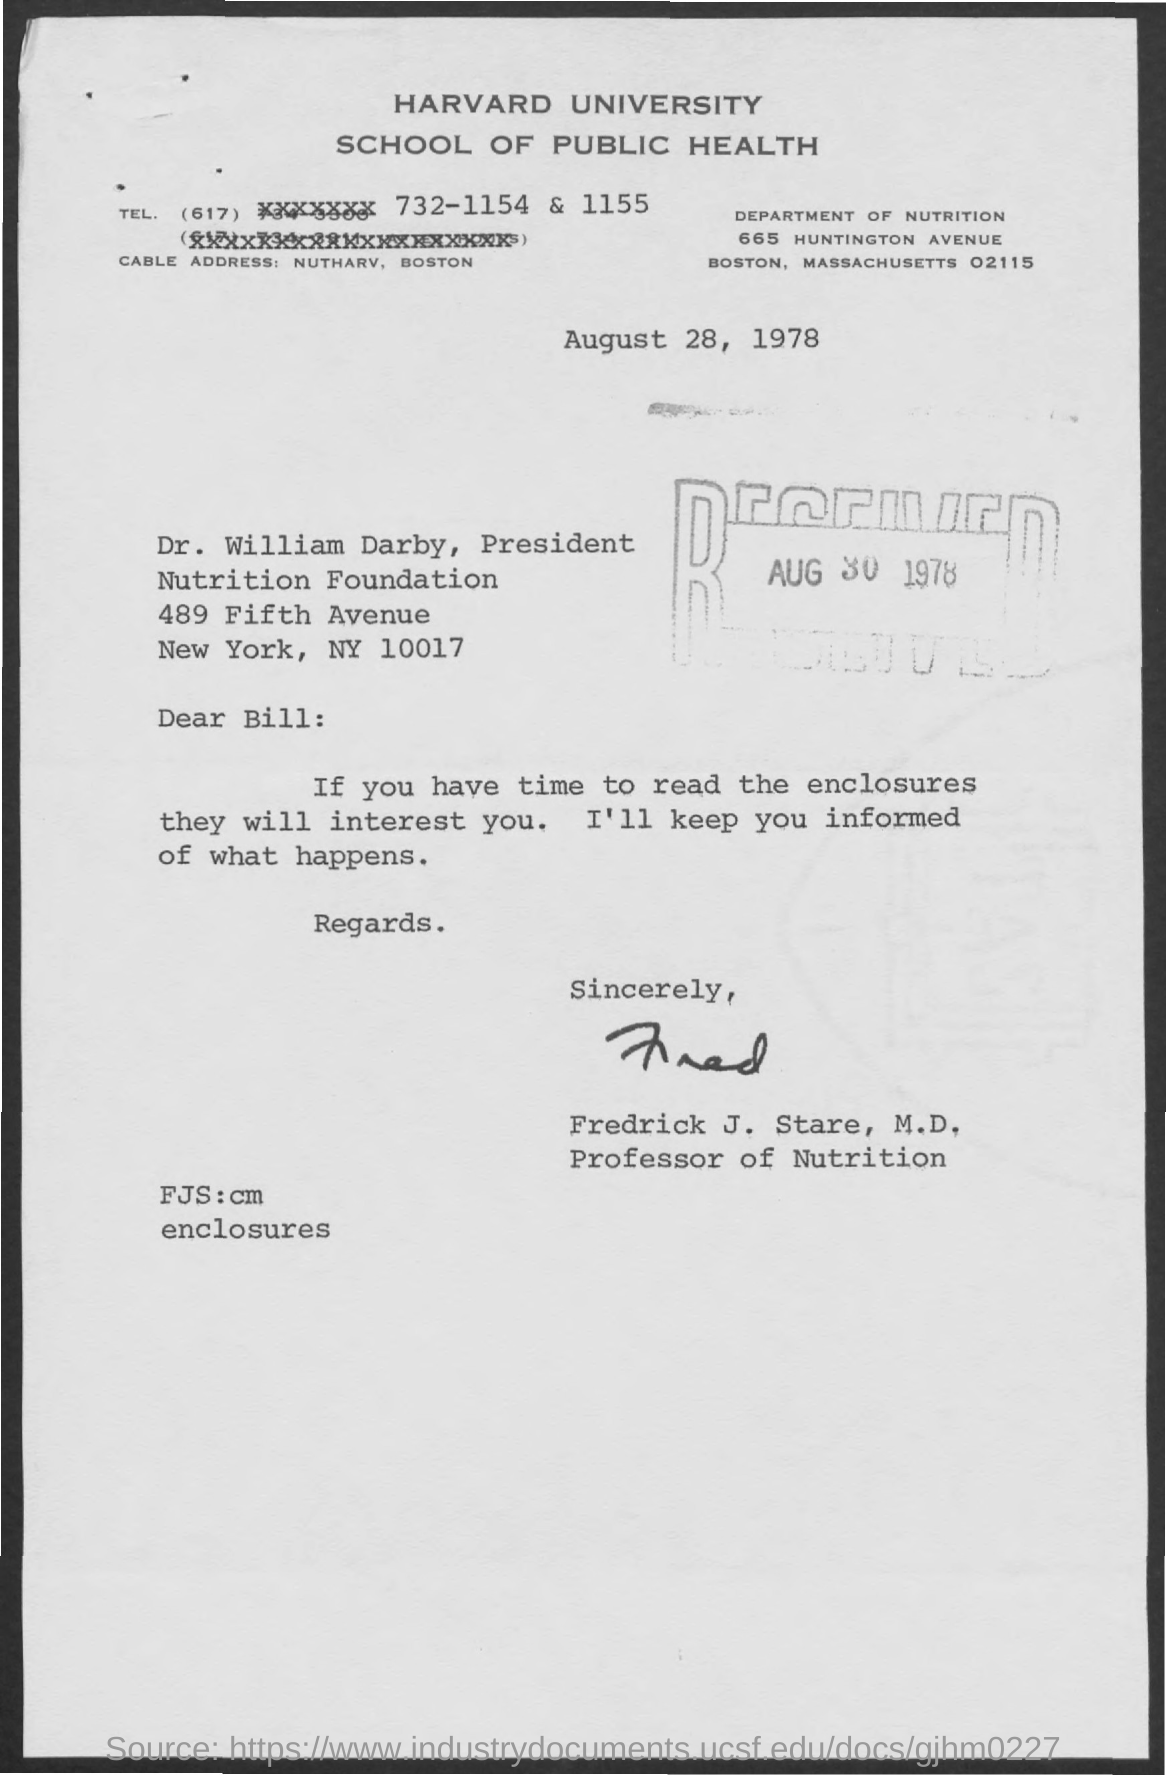Identify some key points in this picture. Frederick J. Stare, a professor of nutrition, has been designated as such. The department mentioned is the Department of Nutrition. The cable address mentioned is "[nutharv, boston](mailto:nutharv, boston)". The name of the university mentioned is Harvard University. The received date mentioned is August 30, 1978. 